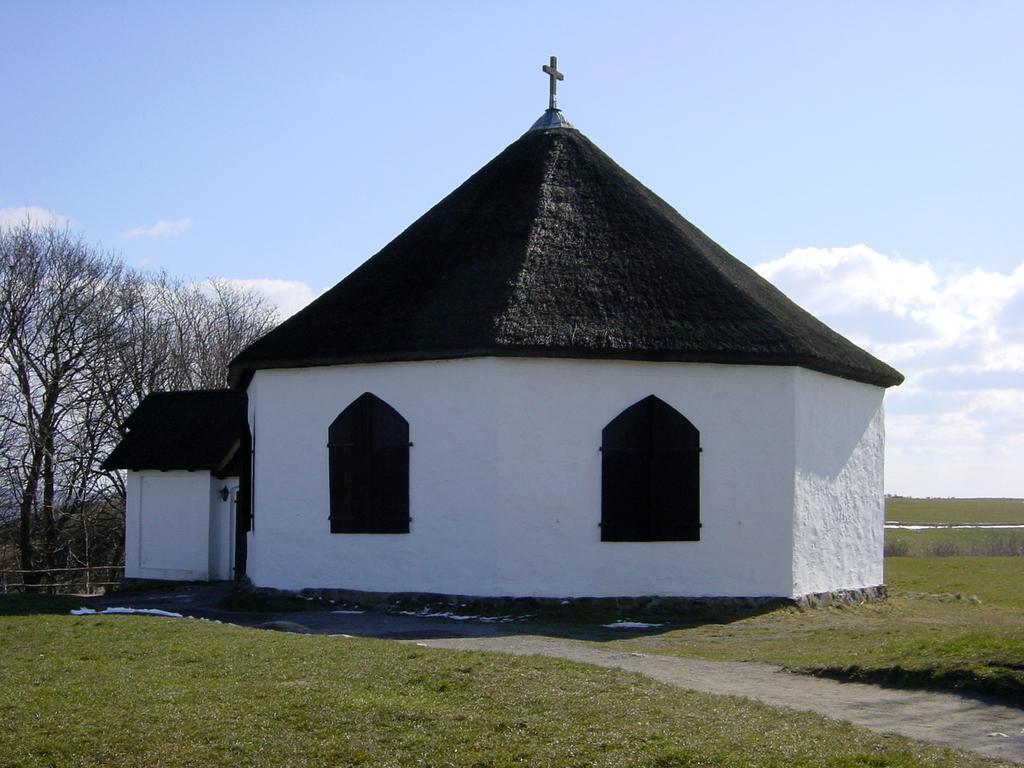Can you describe this image briefly? In the center of the image we can see a building with two windows. On the left side, we can see a group of trees and in the background, we can see the cloudy sky. 